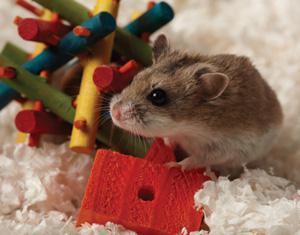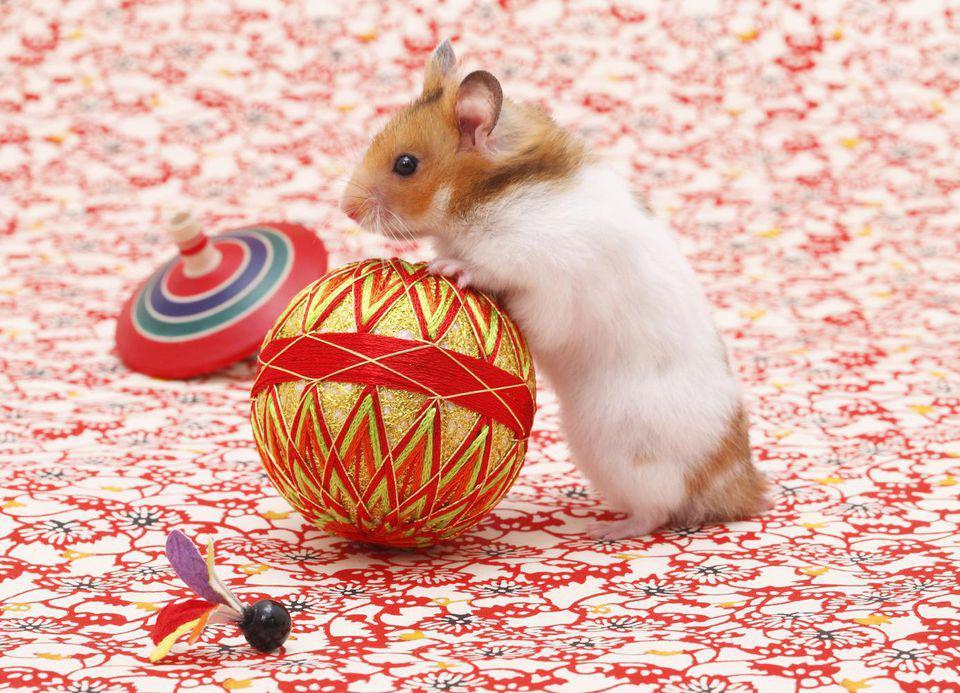The first image is the image on the left, the second image is the image on the right. For the images shown, is this caption "An item perforated with a hole is touched by a rodent standing behind it, in one image." true? Answer yes or no. Yes. The first image is the image on the left, the second image is the image on the right. For the images shown, is this caption "There is at least one human hand touching a rodent." true? Answer yes or no. No. 